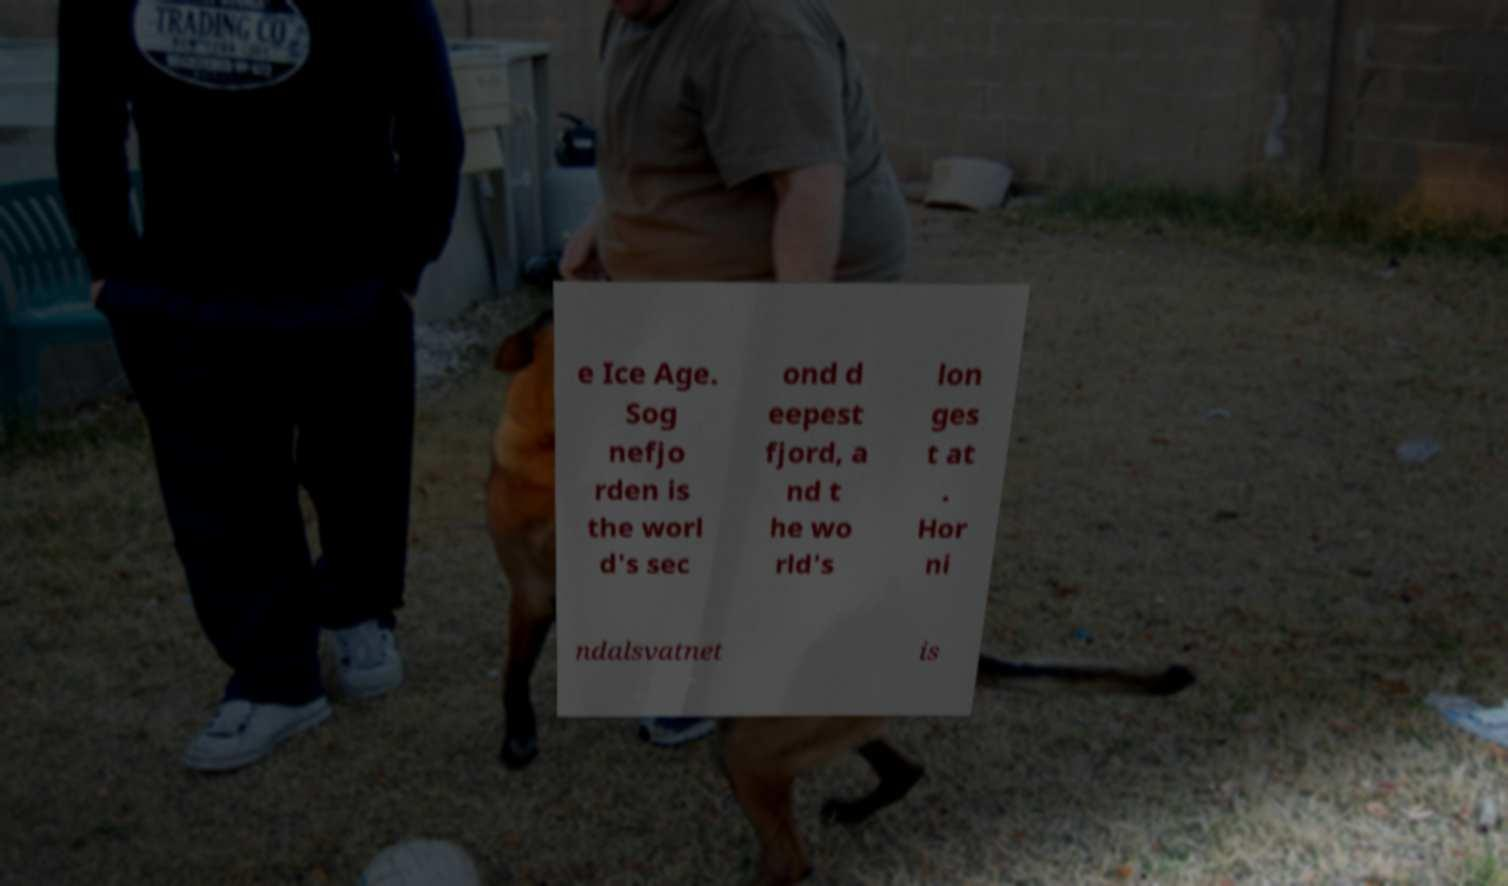Can you accurately transcribe the text from the provided image for me? e Ice Age. Sog nefjo rden is the worl d's sec ond d eepest fjord, a nd t he wo rld's lon ges t at . Hor ni ndalsvatnet is 